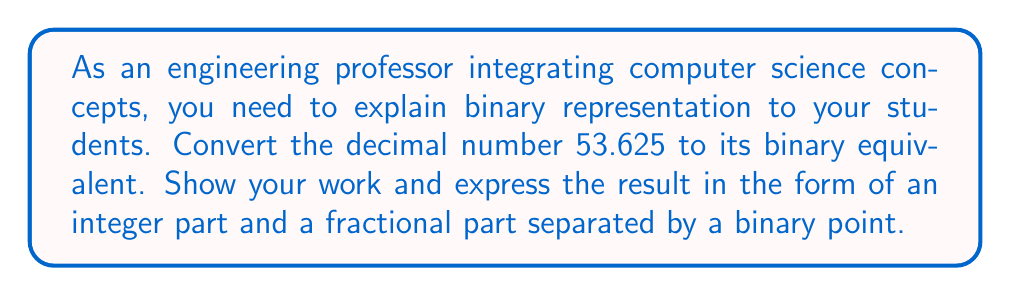Teach me how to tackle this problem. To convert a decimal number with both integer and fractional parts to binary, we need to handle each part separately:

1. For the integer part (53):
   Use the division by 2 method, writing remainders from bottom to top:
   
   $53 \div 2 = 26$ remainder $1$
   $26 \div 2 = 13$ remainder $0$
   $13 \div 2 = 6$  remainder $1$
   $6 \div 2 = 3$   remainder $0$
   $3 \div 2 = 1$   remainder $1$
   $1 \div 2 = 0$   remainder $1$

   Reading the remainders from bottom to top gives: $110101$

2. For the fractional part (0.625):
   Use the multiplication by 2 method, keeping track of the integer parts:
   
   $0.625 \times 2 = 1.25$  Integer part: $1$
   $0.25 \times 2 = 0.5$    Integer part: $0$
   $0.5 \times 2 = 1.0$     Integer part: $1$

   Reading the integer parts from top to bottom gives: $101$

3. Combine the results:
   Integer part: $110101$
   Fractional part: $101$

Therefore, $53.625_{10} = 110101.101_2$
Answer: $53.625_{10} = 110101.101_2$ 